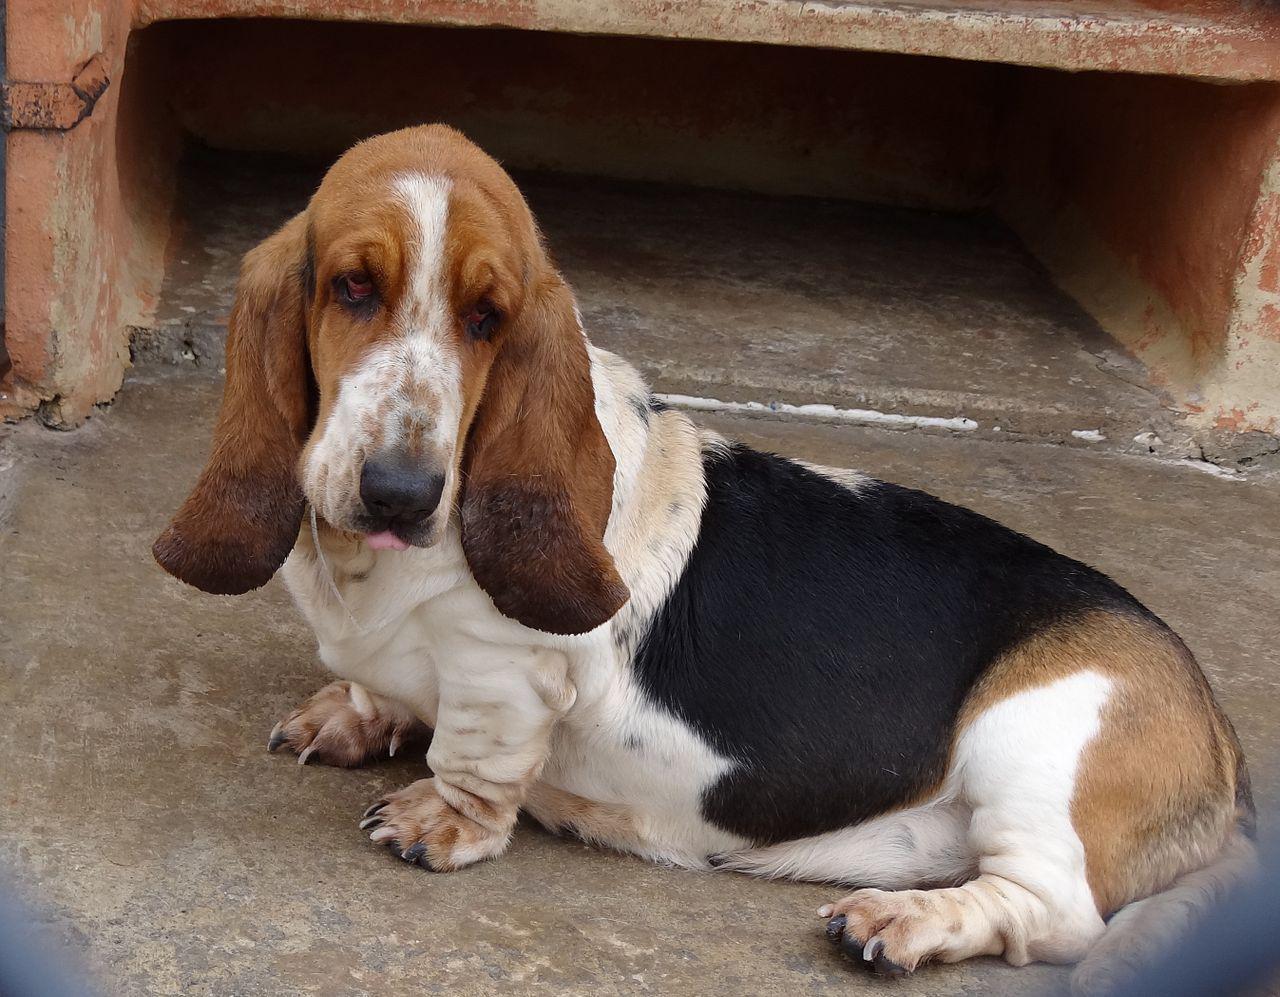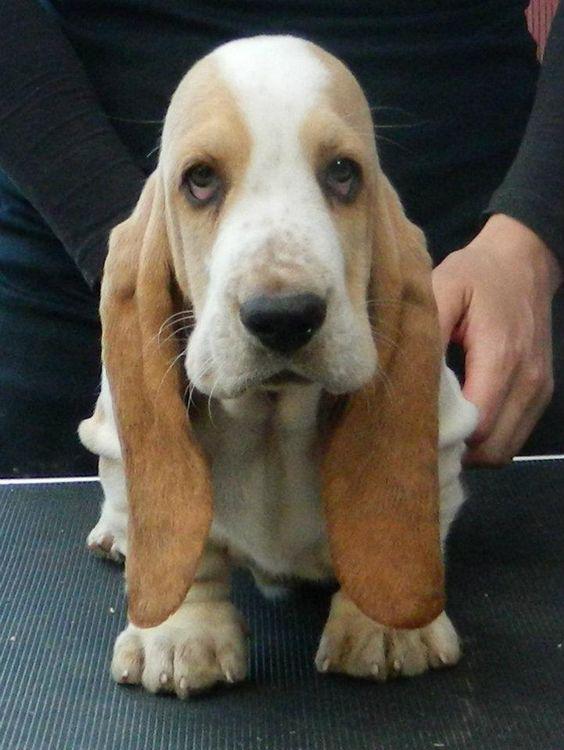The first image is the image on the left, the second image is the image on the right. For the images shown, is this caption "Each image contains exactly one dog, and all dogs are long-eared basset hounds that gaze forward." true? Answer yes or no. Yes. The first image is the image on the left, the second image is the image on the right. For the images shown, is this caption "All the dogs are bloodhounds." true? Answer yes or no. Yes. 